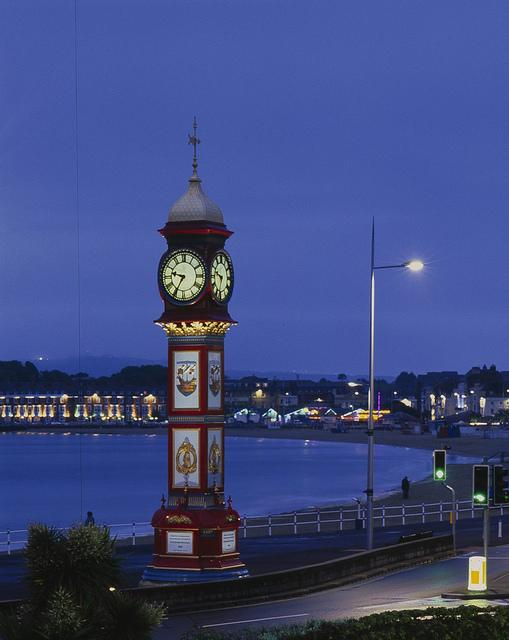What should traffic do by the light? Please explain your reasoning. go. There is a green light which means it is safe to proceed. 